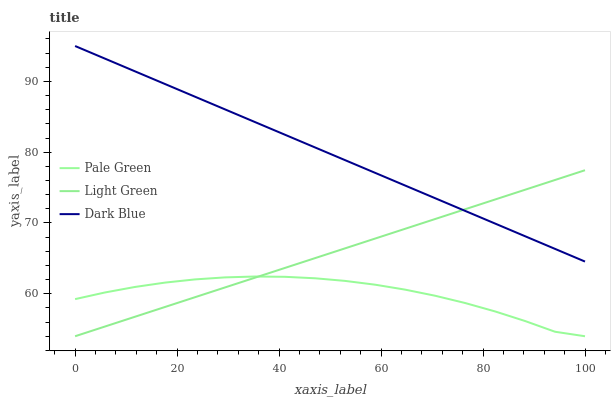Does Pale Green have the minimum area under the curve?
Answer yes or no. Yes. Does Dark Blue have the maximum area under the curve?
Answer yes or no. Yes. Does Light Green have the minimum area under the curve?
Answer yes or no. No. Does Light Green have the maximum area under the curve?
Answer yes or no. No. Is Light Green the smoothest?
Answer yes or no. Yes. Is Pale Green the roughest?
Answer yes or no. Yes. Is Pale Green the smoothest?
Answer yes or no. No. Is Light Green the roughest?
Answer yes or no. No. Does Pale Green have the lowest value?
Answer yes or no. Yes. Does Dark Blue have the highest value?
Answer yes or no. Yes. Does Light Green have the highest value?
Answer yes or no. No. Is Pale Green less than Dark Blue?
Answer yes or no. Yes. Is Dark Blue greater than Pale Green?
Answer yes or no. Yes. Does Dark Blue intersect Light Green?
Answer yes or no. Yes. Is Dark Blue less than Light Green?
Answer yes or no. No. Is Dark Blue greater than Light Green?
Answer yes or no. No. Does Pale Green intersect Dark Blue?
Answer yes or no. No. 